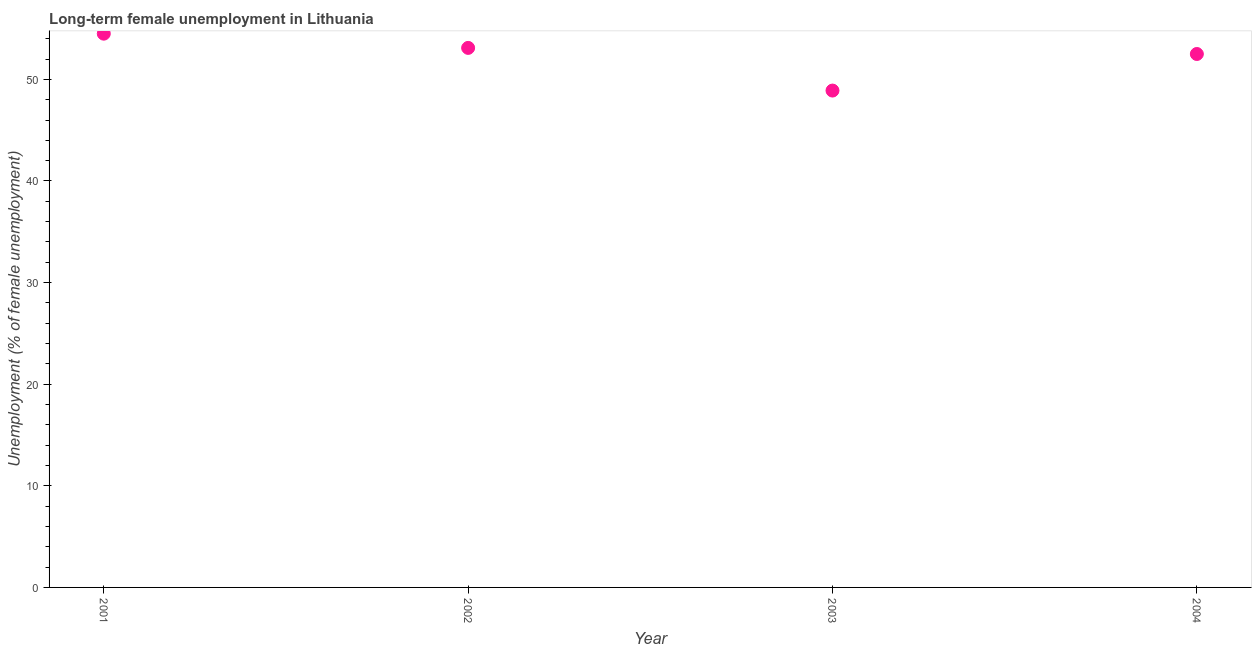What is the long-term female unemployment in 2002?
Your response must be concise. 53.1. Across all years, what is the maximum long-term female unemployment?
Make the answer very short. 54.5. Across all years, what is the minimum long-term female unemployment?
Make the answer very short. 48.9. In which year was the long-term female unemployment minimum?
Your answer should be compact. 2003. What is the sum of the long-term female unemployment?
Provide a succinct answer. 209. What is the difference between the long-term female unemployment in 2001 and 2002?
Provide a succinct answer. 1.4. What is the average long-term female unemployment per year?
Give a very brief answer. 52.25. What is the median long-term female unemployment?
Offer a very short reply. 52.8. What is the ratio of the long-term female unemployment in 2001 to that in 2004?
Offer a terse response. 1.04. What is the difference between the highest and the second highest long-term female unemployment?
Keep it short and to the point. 1.4. What is the difference between the highest and the lowest long-term female unemployment?
Give a very brief answer. 5.6. In how many years, is the long-term female unemployment greater than the average long-term female unemployment taken over all years?
Provide a short and direct response. 3. What is the difference between two consecutive major ticks on the Y-axis?
Your answer should be compact. 10. Are the values on the major ticks of Y-axis written in scientific E-notation?
Keep it short and to the point. No. What is the title of the graph?
Offer a very short reply. Long-term female unemployment in Lithuania. What is the label or title of the X-axis?
Offer a terse response. Year. What is the label or title of the Y-axis?
Provide a succinct answer. Unemployment (% of female unemployment). What is the Unemployment (% of female unemployment) in 2001?
Offer a very short reply. 54.5. What is the Unemployment (% of female unemployment) in 2002?
Your answer should be compact. 53.1. What is the Unemployment (% of female unemployment) in 2003?
Offer a very short reply. 48.9. What is the Unemployment (% of female unemployment) in 2004?
Make the answer very short. 52.5. What is the difference between the Unemployment (% of female unemployment) in 2001 and 2002?
Your answer should be very brief. 1.4. What is the difference between the Unemployment (% of female unemployment) in 2002 and 2004?
Your response must be concise. 0.6. What is the ratio of the Unemployment (% of female unemployment) in 2001 to that in 2003?
Your answer should be compact. 1.11. What is the ratio of the Unemployment (% of female unemployment) in 2001 to that in 2004?
Keep it short and to the point. 1.04. What is the ratio of the Unemployment (% of female unemployment) in 2002 to that in 2003?
Offer a terse response. 1.09. What is the ratio of the Unemployment (% of female unemployment) in 2002 to that in 2004?
Your response must be concise. 1.01. What is the ratio of the Unemployment (% of female unemployment) in 2003 to that in 2004?
Make the answer very short. 0.93. 